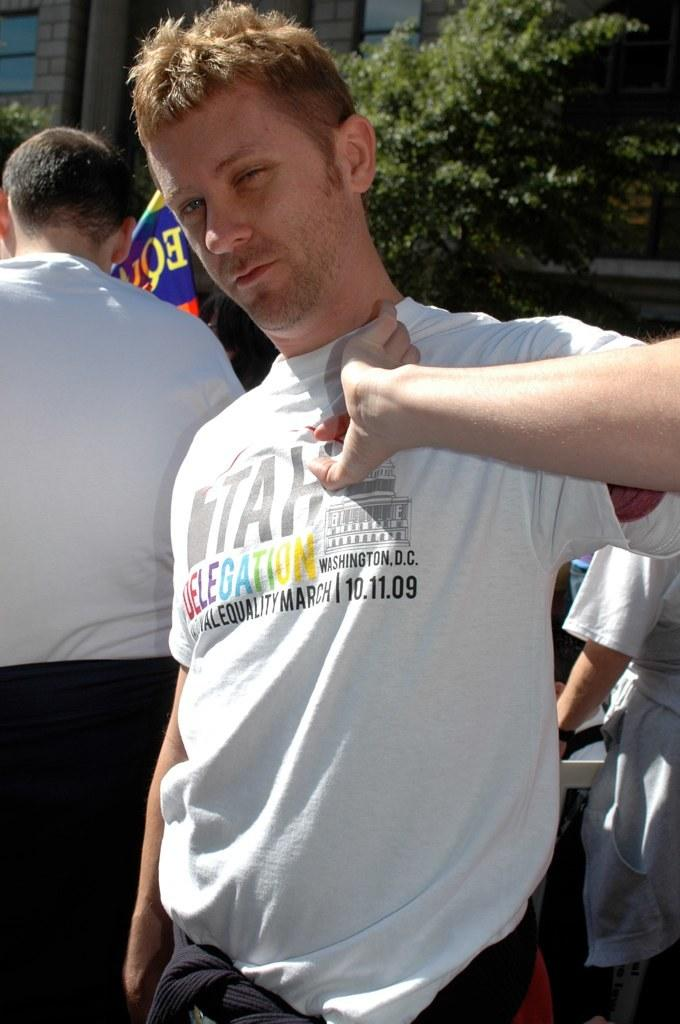How many people are in the image? There are three persons in the image. What are the people wearing? The persons are wearing white T-shirts. What can be seen in the background of the image? There is a building and a tree in the background of the image. What type of card is being used by the persons in the image? There is no card present in the image; the persons are wearing white T-shirts. What type of society is depicted in the image? The image does not depict a society; it shows three persons wearing white T-shirts and the background elements. 